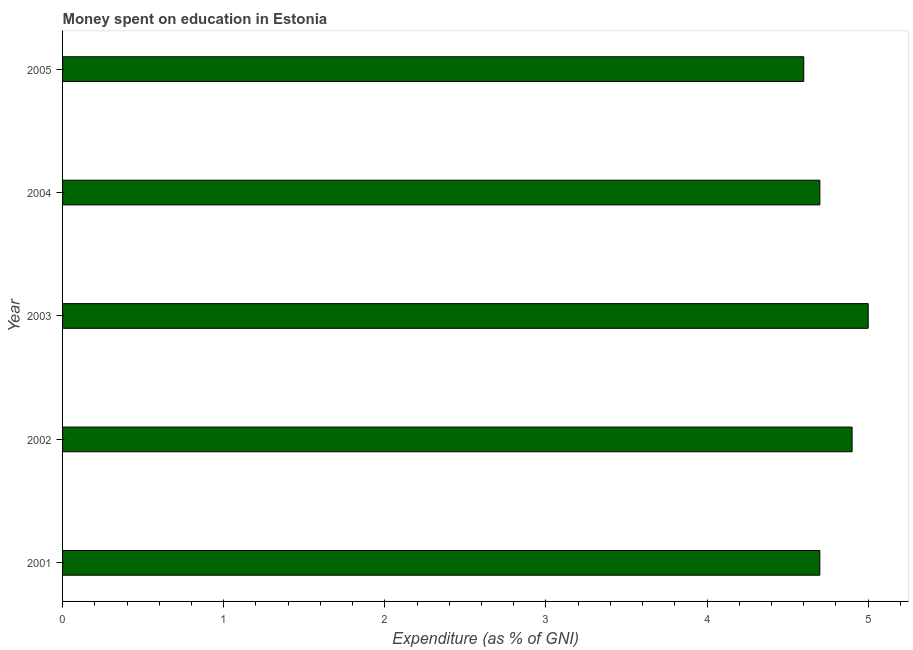Does the graph contain any zero values?
Offer a very short reply. No. What is the title of the graph?
Offer a very short reply. Money spent on education in Estonia. What is the label or title of the X-axis?
Offer a very short reply. Expenditure (as % of GNI). What is the label or title of the Y-axis?
Offer a terse response. Year. In which year was the expenditure on education minimum?
Your answer should be compact. 2005. What is the sum of the expenditure on education?
Provide a short and direct response. 23.9. What is the average expenditure on education per year?
Provide a short and direct response. 4.78. Do a majority of the years between 2003 and 2001 (inclusive) have expenditure on education greater than 0.6 %?
Offer a terse response. Yes. What is the ratio of the expenditure on education in 2001 to that in 2005?
Keep it short and to the point. 1.02. Is the difference between the expenditure on education in 2001 and 2003 greater than the difference between any two years?
Make the answer very short. No. What is the difference between the highest and the second highest expenditure on education?
Offer a terse response. 0.1. Is the sum of the expenditure on education in 2001 and 2005 greater than the maximum expenditure on education across all years?
Your answer should be very brief. Yes. What is the difference between the highest and the lowest expenditure on education?
Make the answer very short. 0.4. In how many years, is the expenditure on education greater than the average expenditure on education taken over all years?
Offer a very short reply. 2. Are all the bars in the graph horizontal?
Your answer should be very brief. Yes. How many years are there in the graph?
Your answer should be very brief. 5. What is the difference between two consecutive major ticks on the X-axis?
Your response must be concise. 1. Are the values on the major ticks of X-axis written in scientific E-notation?
Keep it short and to the point. No. What is the Expenditure (as % of GNI) in 2001?
Your response must be concise. 4.7. What is the Expenditure (as % of GNI) of 2002?
Ensure brevity in your answer.  4.9. What is the Expenditure (as % of GNI) of 2005?
Your response must be concise. 4.6. What is the difference between the Expenditure (as % of GNI) in 2001 and 2002?
Your answer should be very brief. -0.2. What is the difference between the Expenditure (as % of GNI) in 2001 and 2003?
Your answer should be compact. -0.3. What is the difference between the Expenditure (as % of GNI) in 2001 and 2004?
Make the answer very short. -0. What is the difference between the Expenditure (as % of GNI) in 2001 and 2005?
Keep it short and to the point. 0.1. What is the difference between the Expenditure (as % of GNI) in 2002 and 2004?
Keep it short and to the point. 0.2. What is the difference between the Expenditure (as % of GNI) in 2003 and 2005?
Your answer should be compact. 0.4. What is the difference between the Expenditure (as % of GNI) in 2004 and 2005?
Make the answer very short. 0.1. What is the ratio of the Expenditure (as % of GNI) in 2001 to that in 2002?
Make the answer very short. 0.96. What is the ratio of the Expenditure (as % of GNI) in 2001 to that in 2003?
Ensure brevity in your answer.  0.94. What is the ratio of the Expenditure (as % of GNI) in 2001 to that in 2004?
Give a very brief answer. 1. What is the ratio of the Expenditure (as % of GNI) in 2002 to that in 2004?
Give a very brief answer. 1.04. What is the ratio of the Expenditure (as % of GNI) in 2002 to that in 2005?
Ensure brevity in your answer.  1.06. What is the ratio of the Expenditure (as % of GNI) in 2003 to that in 2004?
Provide a short and direct response. 1.06. What is the ratio of the Expenditure (as % of GNI) in 2003 to that in 2005?
Ensure brevity in your answer.  1.09. What is the ratio of the Expenditure (as % of GNI) in 2004 to that in 2005?
Offer a terse response. 1.02. 